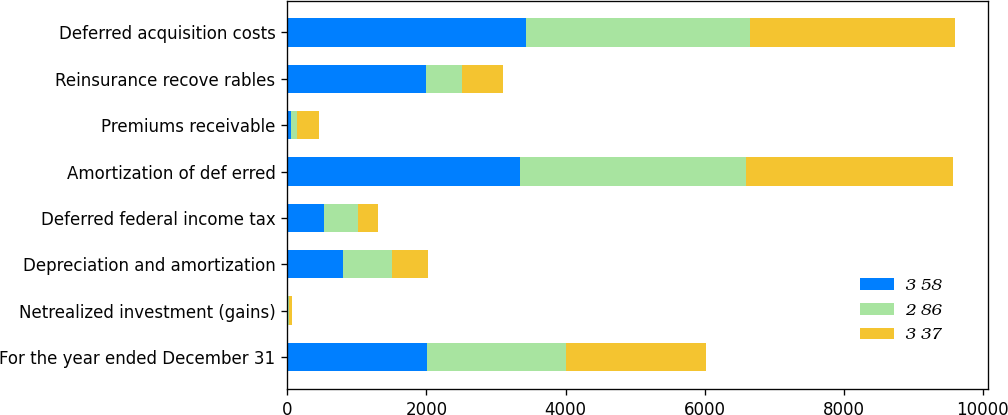<chart> <loc_0><loc_0><loc_500><loc_500><stacked_bar_chart><ecel><fcel>For the year ended December 31<fcel>Netrealized investment (gains)<fcel>Depreciation and amortization<fcel>Deferred federal income tax<fcel>Amortization of def erred<fcel>Premiums receivable<fcel>Reinsurance recove rables<fcel>Deferred acquisition costs<nl><fcel>3 58<fcel>2006<fcel>11<fcel>808<fcel>521<fcel>3339<fcel>57<fcel>1998<fcel>3427<nl><fcel>2 86<fcel>2005<fcel>17<fcel>691<fcel>500<fcel>3252<fcel>77<fcel>520<fcel>3220<nl><fcel>3 37<fcel>2004<fcel>39<fcel>522<fcel>280<fcel>2978<fcel>320<fcel>584<fcel>2948<nl></chart> 